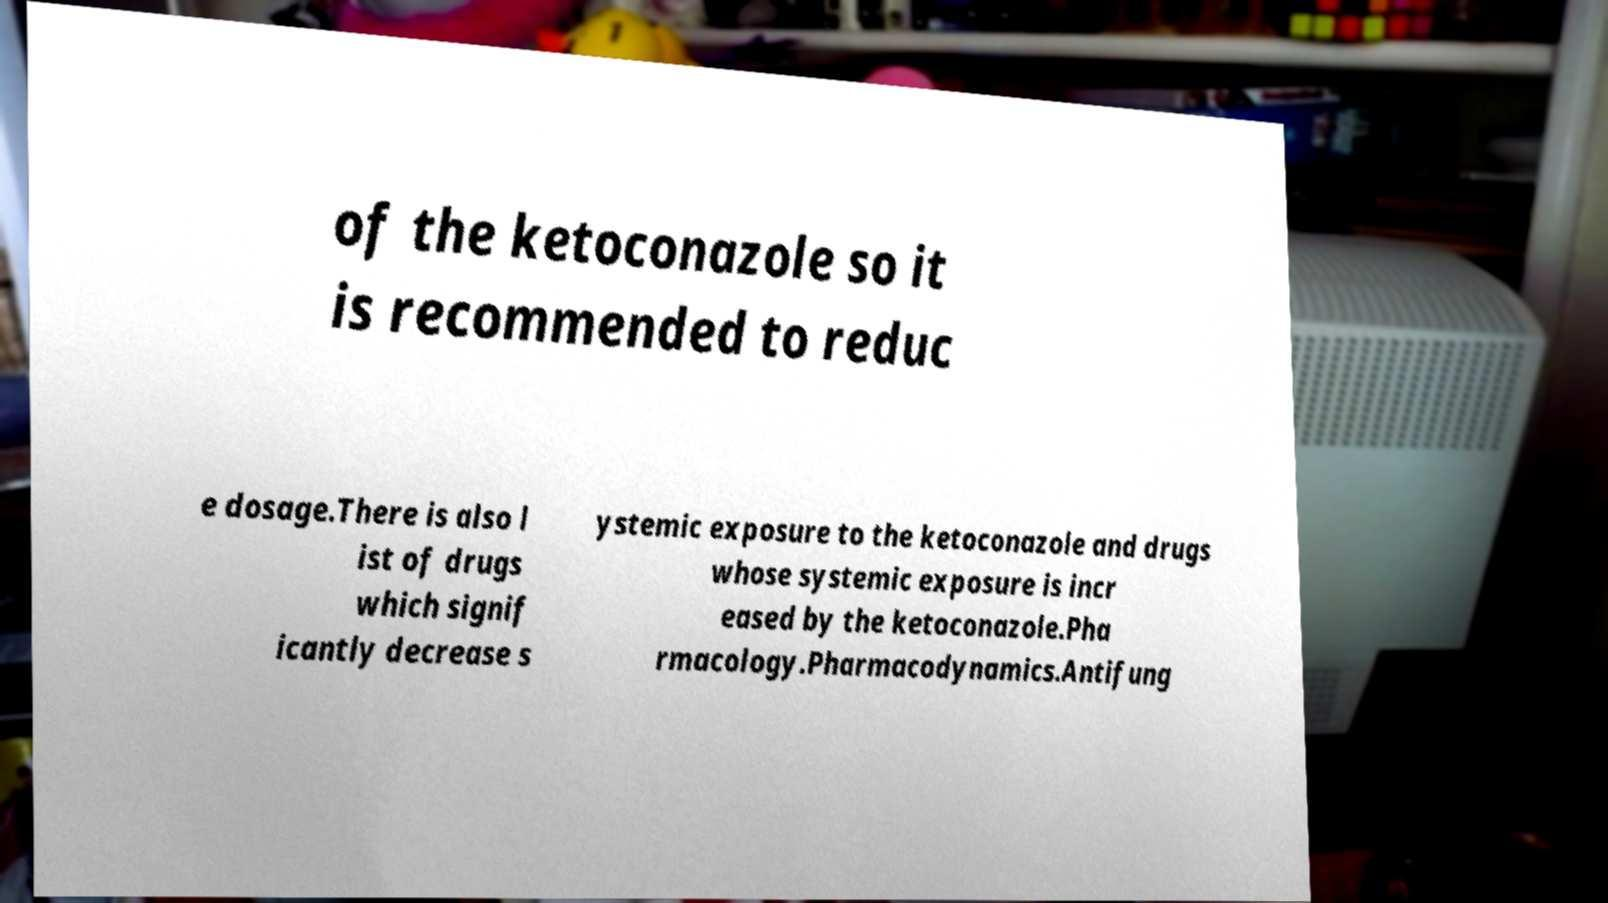Could you extract and type out the text from this image? of the ketoconazole so it is recommended to reduc e dosage.There is also l ist of drugs which signif icantly decrease s ystemic exposure to the ketoconazole and drugs whose systemic exposure is incr eased by the ketoconazole.Pha rmacology.Pharmacodynamics.Antifung 